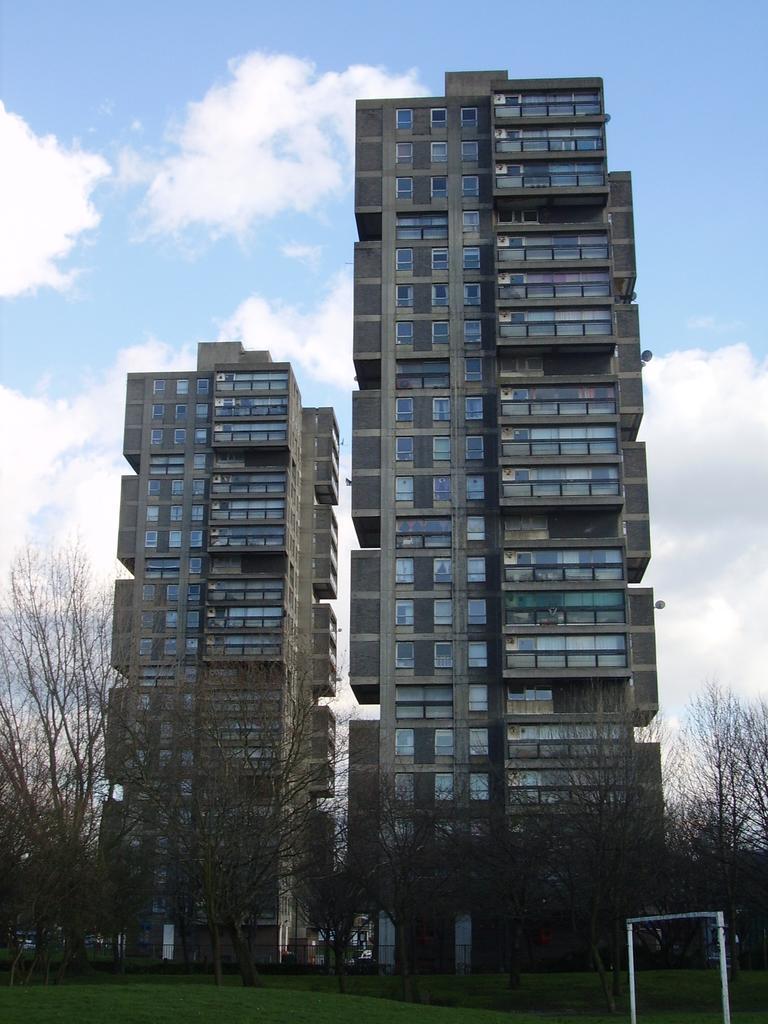In one or two sentences, can you explain what this image depicts? In this picture I can see buildings, trees, grass and a white color object on the ground. In the background I can see the sky. 